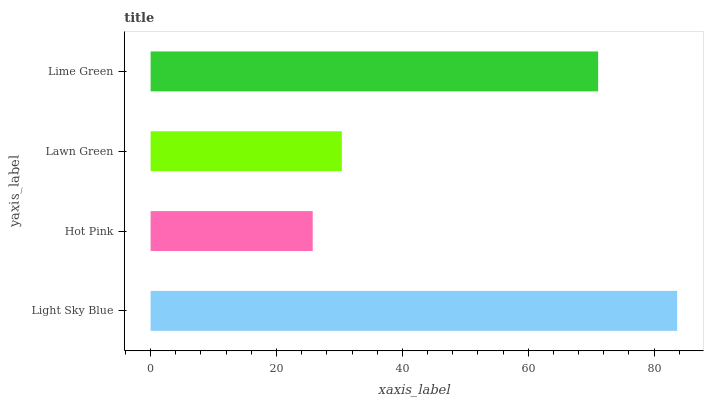Is Hot Pink the minimum?
Answer yes or no. Yes. Is Light Sky Blue the maximum?
Answer yes or no. Yes. Is Lawn Green the minimum?
Answer yes or no. No. Is Lawn Green the maximum?
Answer yes or no. No. Is Lawn Green greater than Hot Pink?
Answer yes or no. Yes. Is Hot Pink less than Lawn Green?
Answer yes or no. Yes. Is Hot Pink greater than Lawn Green?
Answer yes or no. No. Is Lawn Green less than Hot Pink?
Answer yes or no. No. Is Lime Green the high median?
Answer yes or no. Yes. Is Lawn Green the low median?
Answer yes or no. Yes. Is Hot Pink the high median?
Answer yes or no. No. Is Hot Pink the low median?
Answer yes or no. No. 